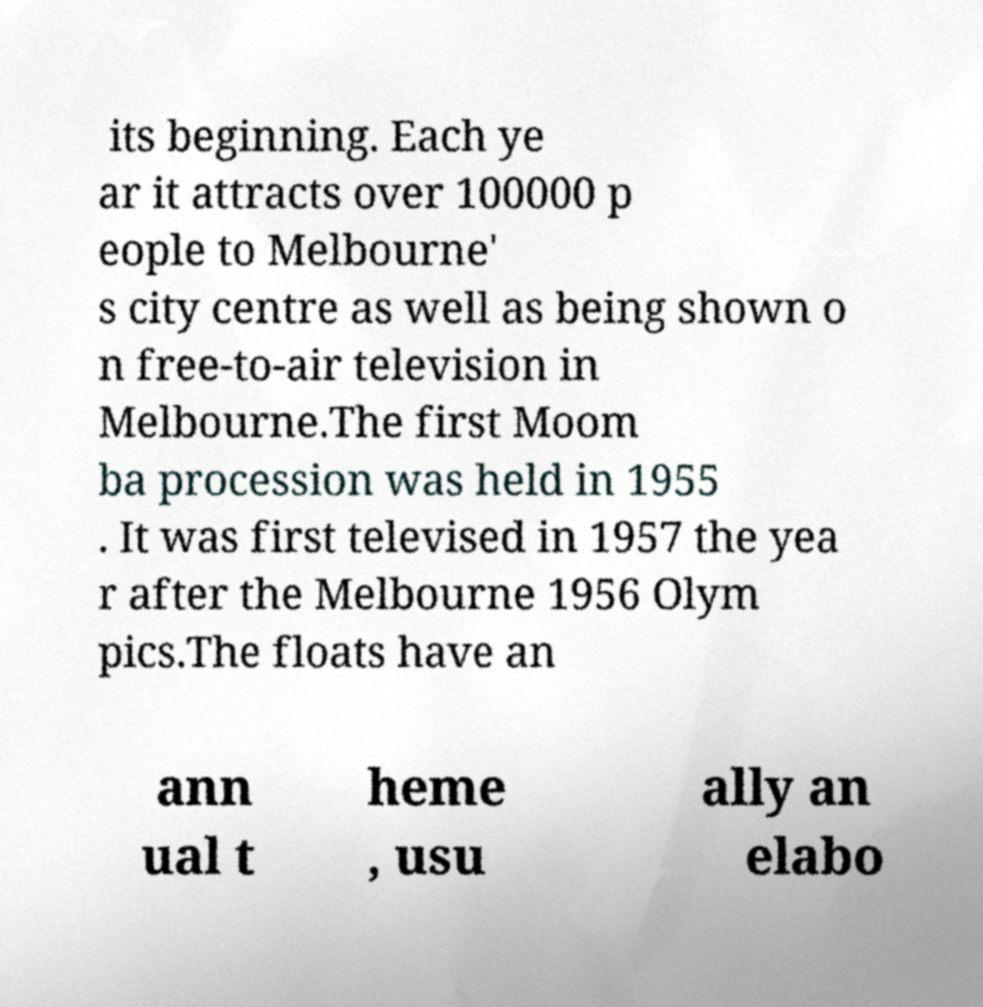What messages or text are displayed in this image? I need them in a readable, typed format. its beginning. Each ye ar it attracts over 100000 p eople to Melbourne' s city centre as well as being shown o n free-to-air television in Melbourne.The first Moom ba procession was held in 1955 . It was first televised in 1957 the yea r after the Melbourne 1956 Olym pics.The floats have an ann ual t heme , usu ally an elabo 